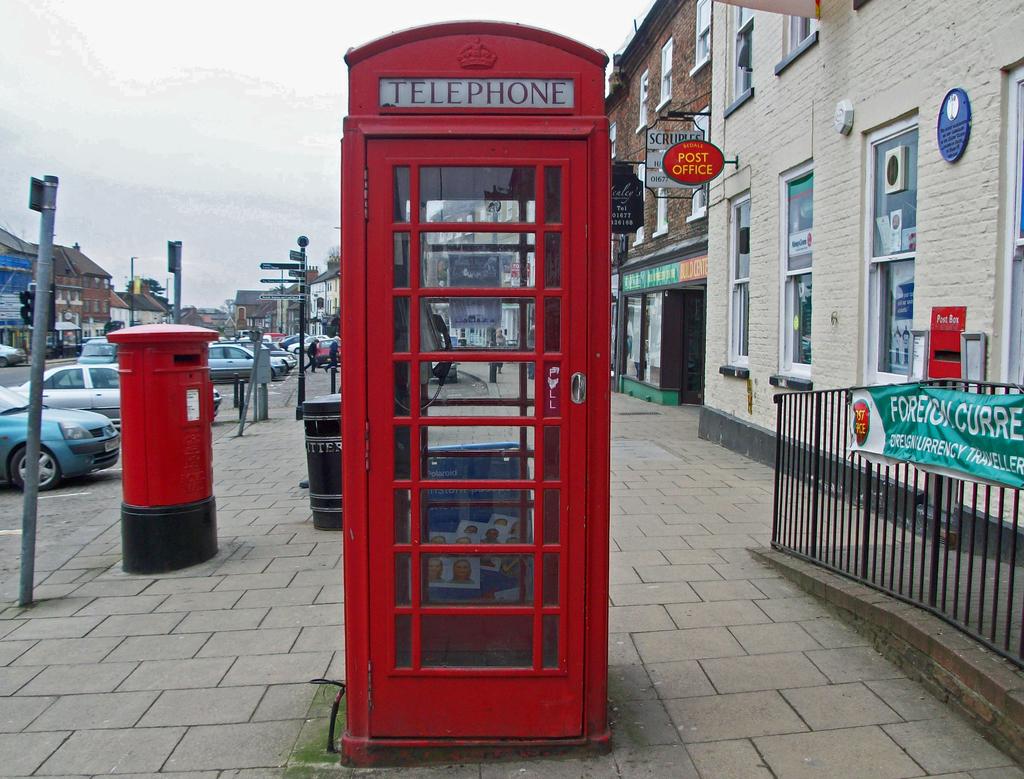What kind of booth is this?
Provide a succinct answer. Telephone. What does it say on the red sign to the right to the phone booth?
Provide a short and direct response. Post office. 